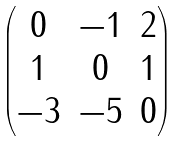<formula> <loc_0><loc_0><loc_500><loc_500>\begin{pmatrix} 0 & - 1 & 2 \\ 1 & 0 & 1 \\ - 3 & - 5 & 0 \end{pmatrix}</formula> 